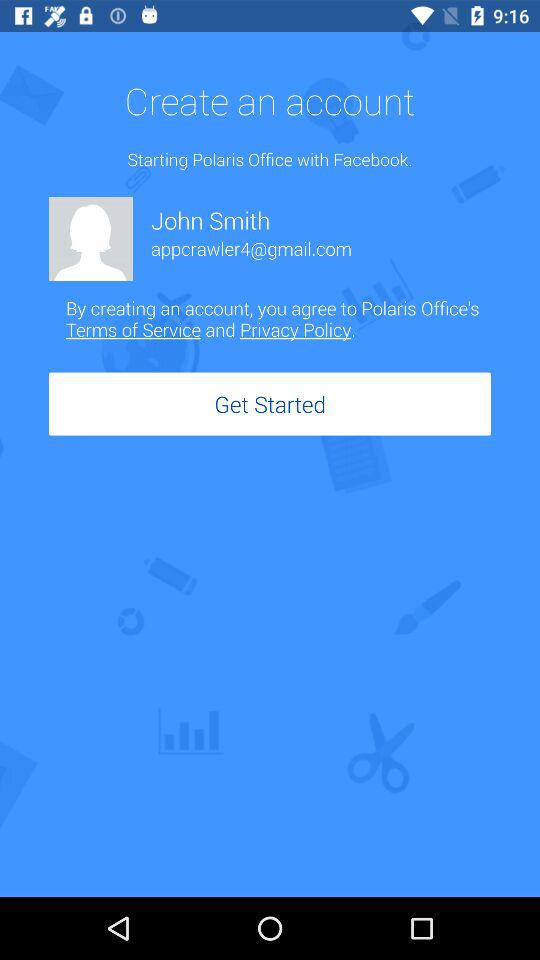What is the email address? The email address is appcrawler4@gmail.com. 